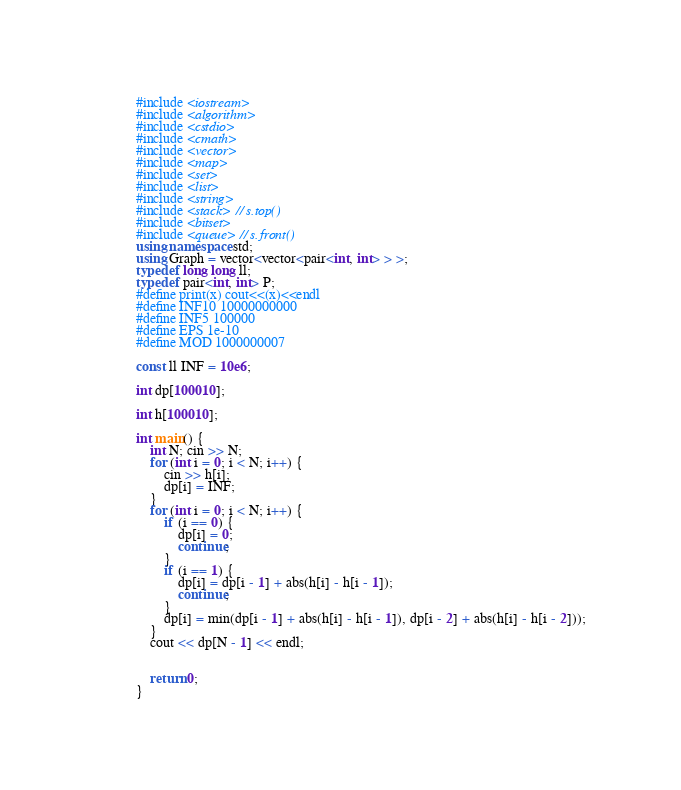<code> <loc_0><loc_0><loc_500><loc_500><_C++_>#include <iostream>
#include <algorithm>
#include <cstdio>
#include <cmath>
#include <vector>
#include <map>
#include <set>
#include <list>
#include <string>
#include <stack> // s.top()
#include <bitset>
#include <queue> // s.front()
using namespace std;
using Graph = vector<vector<pair<int, int> > >;
typedef long long ll;
typedef pair<int, int> P;
#define print(x) cout<<(x)<<endl
#define INF10 10000000000
#define INF5 100000
#define EPS 1e-10
#define MOD 1000000007

const ll INF = 10e6;

int dp[100010];

int h[100010];

int main() {
	int N; cin >> N;
	for (int i = 0; i < N; i++) {
		cin >> h[i];
		dp[i] = INF;
	}
	for (int i = 0; i < N; i++) {
		if (i == 0) {
			dp[i] = 0;
			continue;
		}
		if (i == 1) {
			dp[i] = dp[i - 1] + abs(h[i] - h[i - 1]);
			continue;
		}
		dp[i] = min(dp[i - 1] + abs(h[i] - h[i - 1]), dp[i - 2] + abs(h[i] - h[i - 2]));
	}
	cout << dp[N - 1] << endl;


	return 0;
}
</code> 